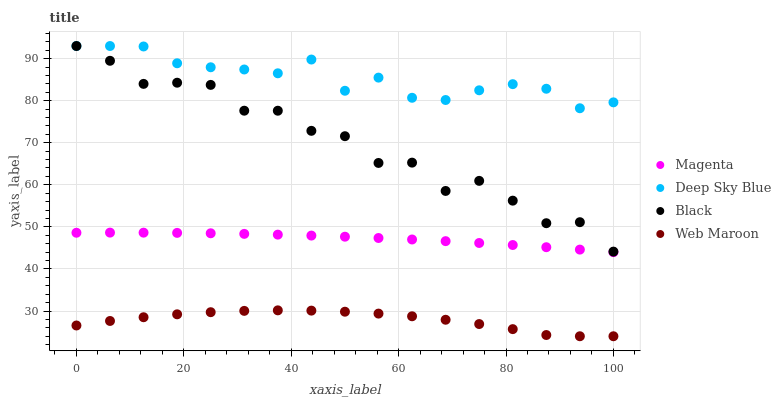Does Web Maroon have the minimum area under the curve?
Answer yes or no. Yes. Does Deep Sky Blue have the maximum area under the curve?
Answer yes or no. Yes. Does Magenta have the minimum area under the curve?
Answer yes or no. No. Does Magenta have the maximum area under the curve?
Answer yes or no. No. Is Magenta the smoothest?
Answer yes or no. Yes. Is Black the roughest?
Answer yes or no. Yes. Is Black the smoothest?
Answer yes or no. No. Is Magenta the roughest?
Answer yes or no. No. Does Web Maroon have the lowest value?
Answer yes or no. Yes. Does Magenta have the lowest value?
Answer yes or no. No. Does Deep Sky Blue have the highest value?
Answer yes or no. Yes. Does Magenta have the highest value?
Answer yes or no. No. Is Magenta less than Black?
Answer yes or no. Yes. Is Magenta greater than Web Maroon?
Answer yes or no. Yes. Does Deep Sky Blue intersect Black?
Answer yes or no. Yes. Is Deep Sky Blue less than Black?
Answer yes or no. No. Is Deep Sky Blue greater than Black?
Answer yes or no. No. Does Magenta intersect Black?
Answer yes or no. No. 